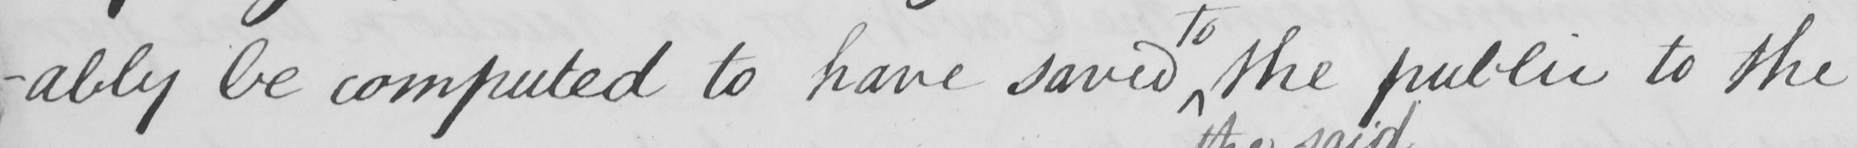Can you tell me what this handwritten text says? -ably be computed to have save the public to the 